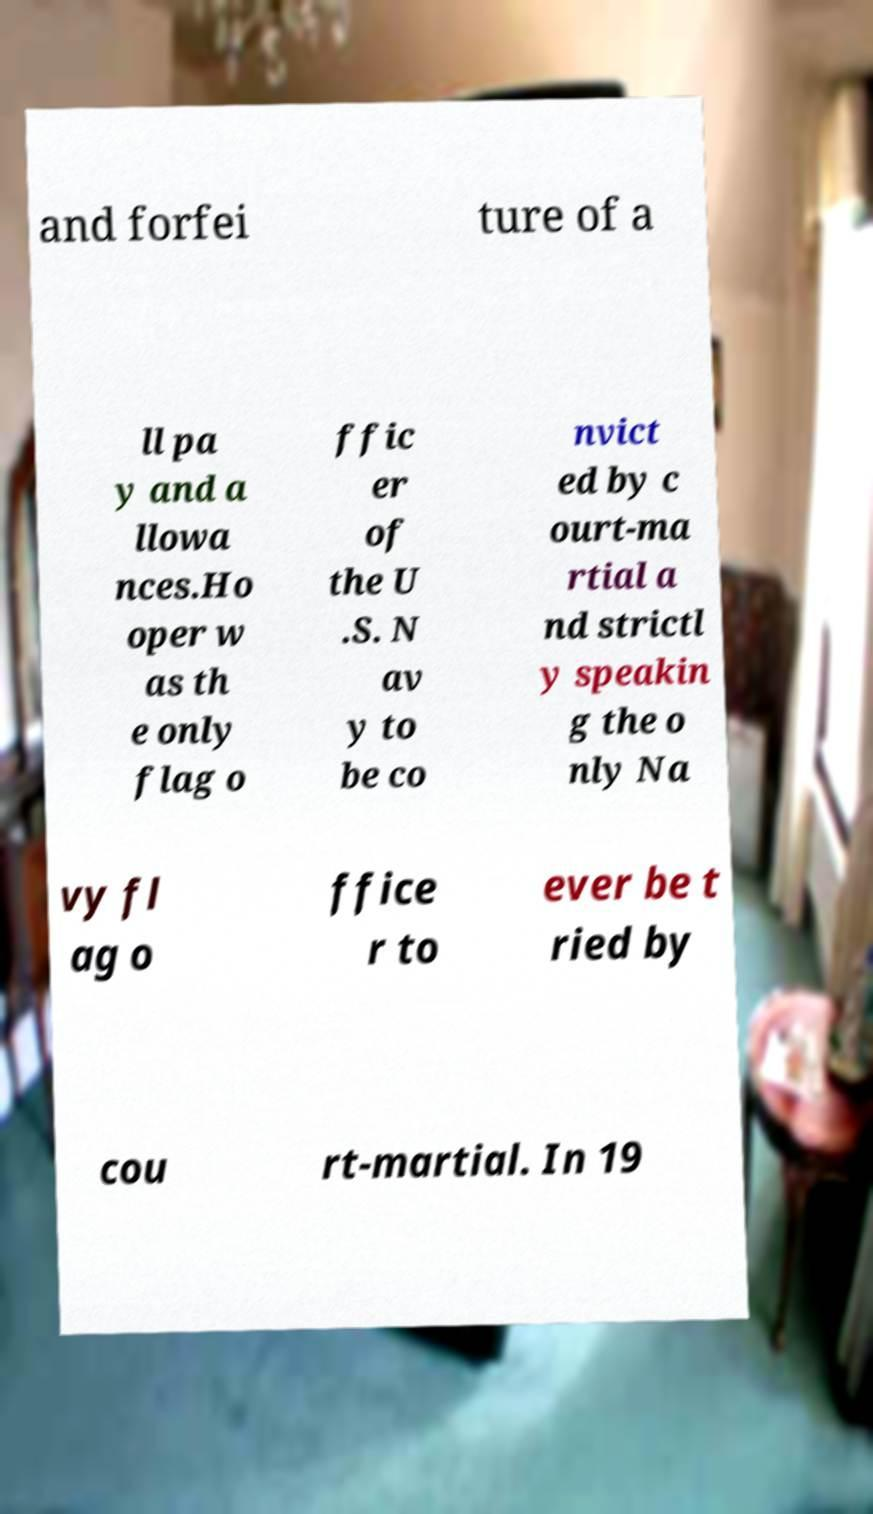Could you assist in decoding the text presented in this image and type it out clearly? and forfei ture of a ll pa y and a llowa nces.Ho oper w as th e only flag o ffic er of the U .S. N av y to be co nvict ed by c ourt-ma rtial a nd strictl y speakin g the o nly Na vy fl ag o ffice r to ever be t ried by cou rt-martial. In 19 